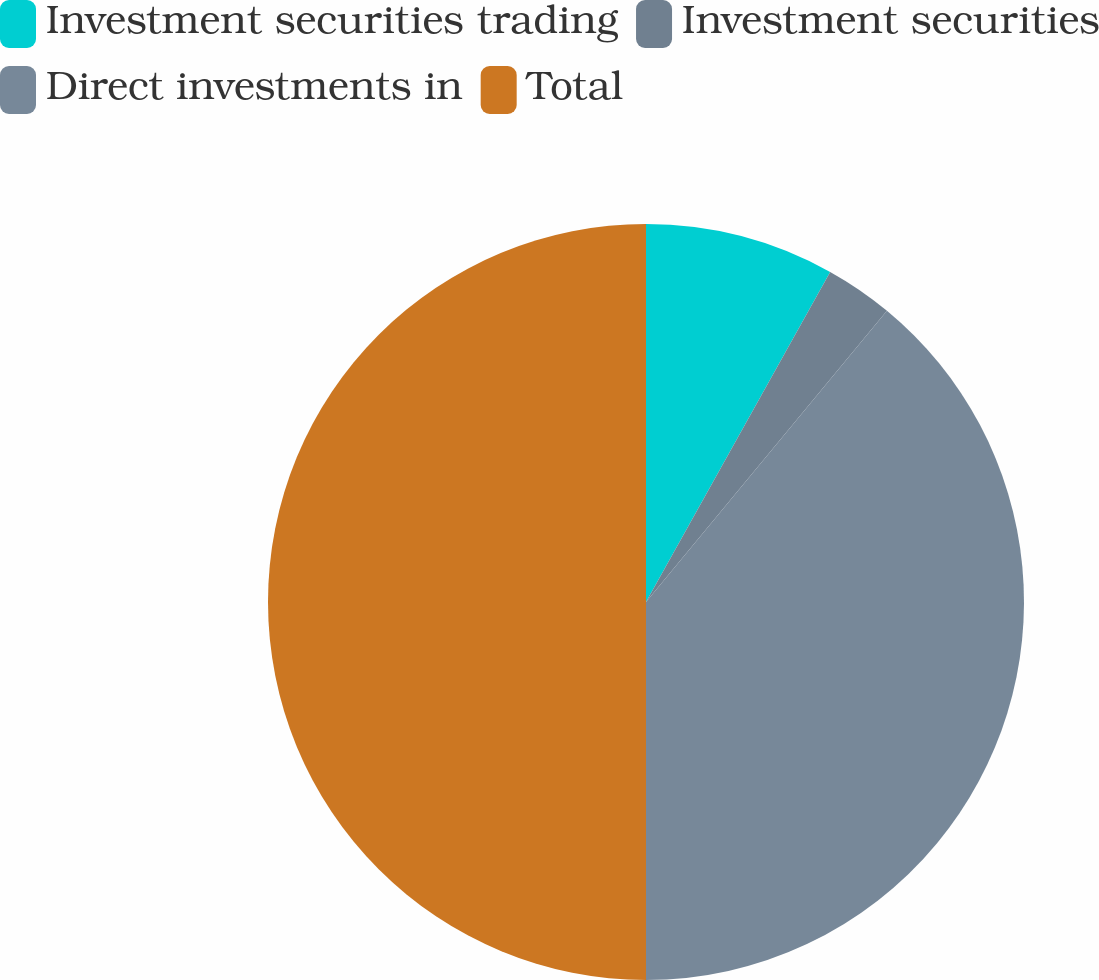<chart> <loc_0><loc_0><loc_500><loc_500><pie_chart><fcel>Investment securities trading<fcel>Investment securities<fcel>Direct investments in<fcel>Total<nl><fcel>8.1%<fcel>2.9%<fcel>39.0%<fcel>50.0%<nl></chart> 